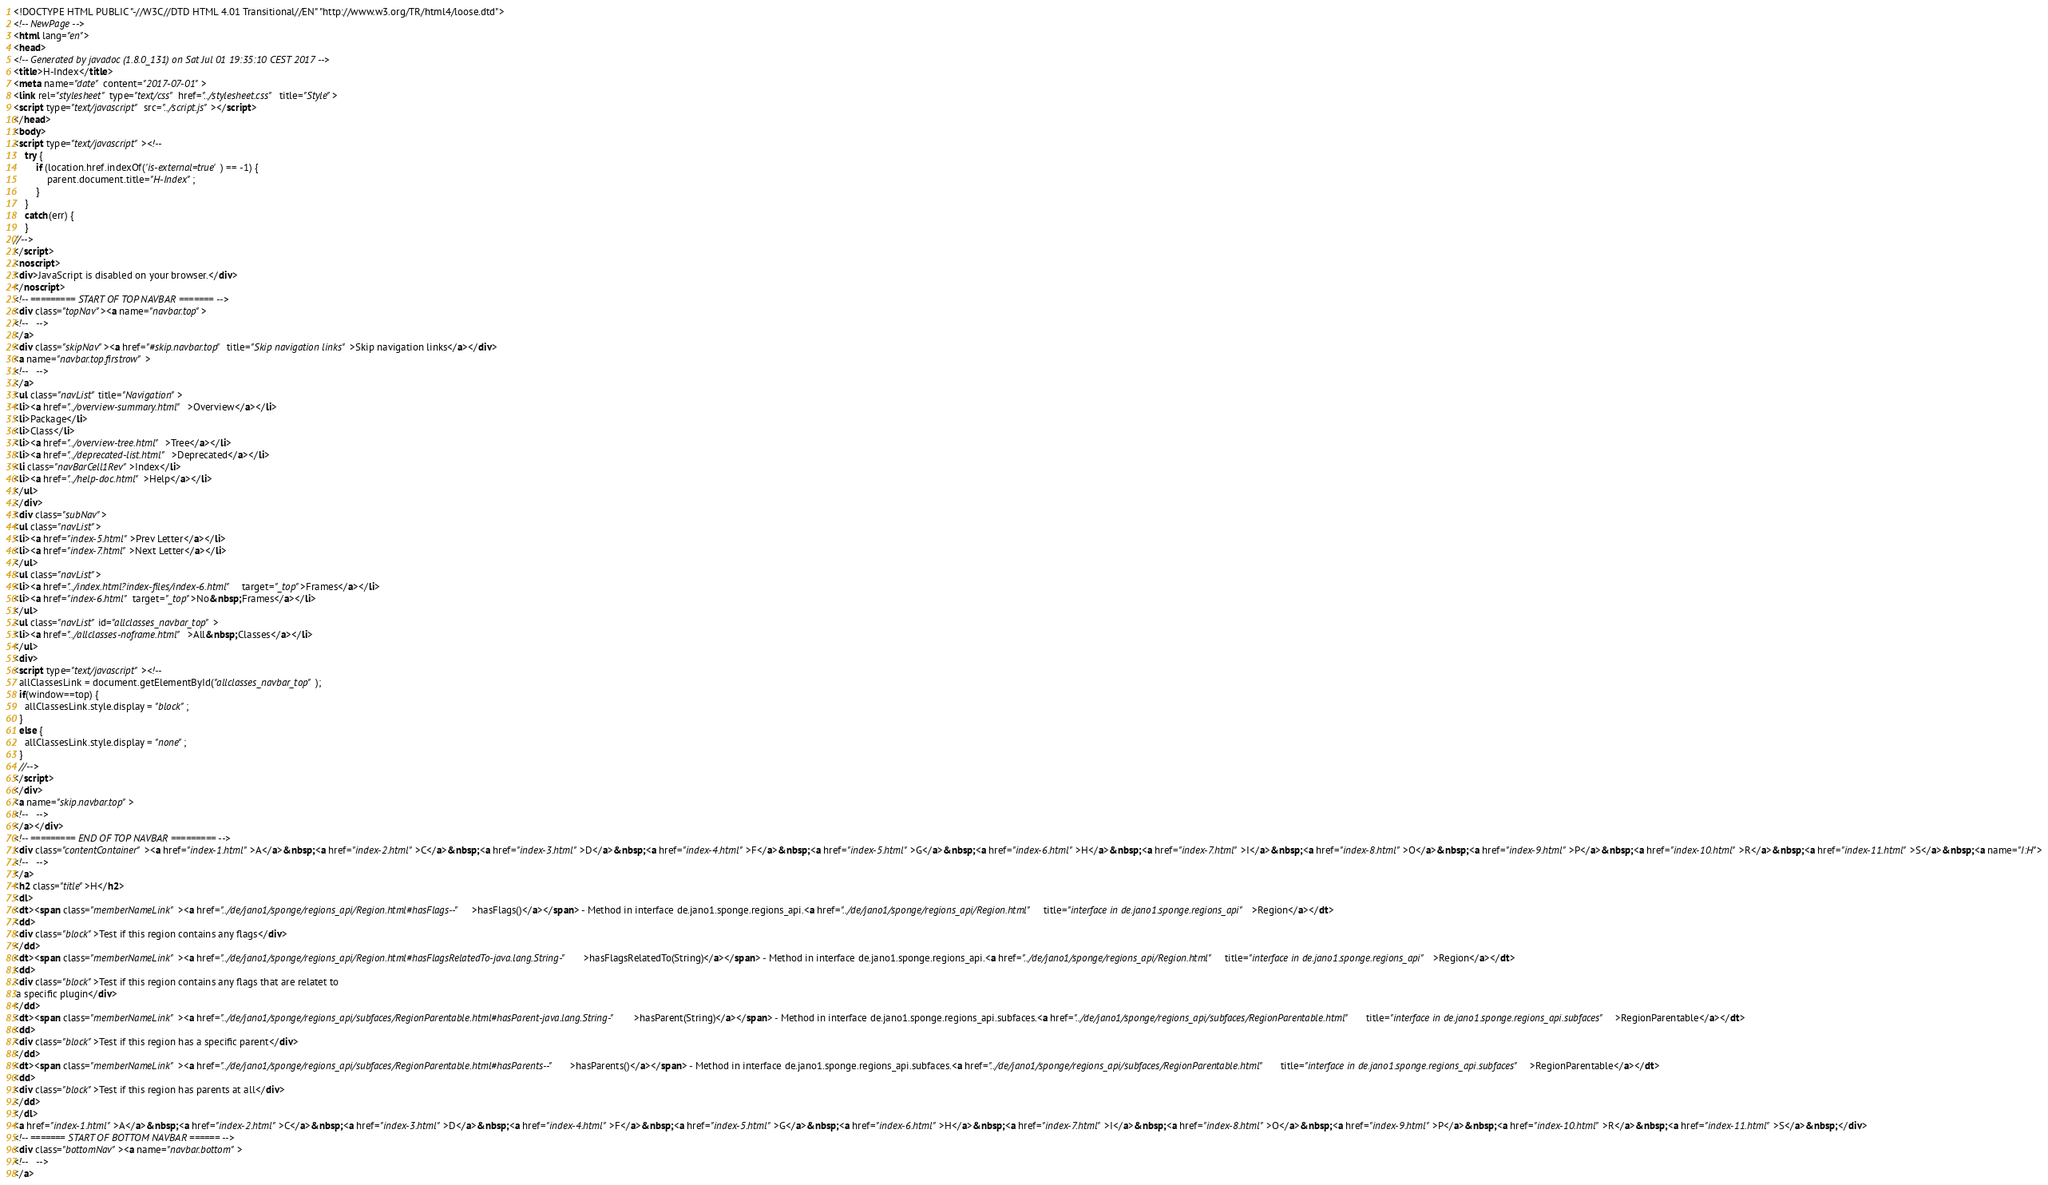<code> <loc_0><loc_0><loc_500><loc_500><_HTML_><!DOCTYPE HTML PUBLIC "-//W3C//DTD HTML 4.01 Transitional//EN" "http://www.w3.org/TR/html4/loose.dtd">
<!-- NewPage -->
<html lang="en">
<head>
<!-- Generated by javadoc (1.8.0_131) on Sat Jul 01 19:35:10 CEST 2017 -->
<title>H-Index</title>
<meta name="date" content="2017-07-01">
<link rel="stylesheet" type="text/css" href="../stylesheet.css" title="Style">
<script type="text/javascript" src="../script.js"></script>
</head>
<body>
<script type="text/javascript"><!--
    try {
        if (location.href.indexOf('is-external=true') == -1) {
            parent.document.title="H-Index";
        }
    }
    catch(err) {
    }
//-->
</script>
<noscript>
<div>JavaScript is disabled on your browser.</div>
</noscript>
<!-- ========= START OF TOP NAVBAR ======= -->
<div class="topNav"><a name="navbar.top">
<!--   -->
</a>
<div class="skipNav"><a href="#skip.navbar.top" title="Skip navigation links">Skip navigation links</a></div>
<a name="navbar.top.firstrow">
<!--   -->
</a>
<ul class="navList" title="Navigation">
<li><a href="../overview-summary.html">Overview</a></li>
<li>Package</li>
<li>Class</li>
<li><a href="../overview-tree.html">Tree</a></li>
<li><a href="../deprecated-list.html">Deprecated</a></li>
<li class="navBarCell1Rev">Index</li>
<li><a href="../help-doc.html">Help</a></li>
</ul>
</div>
<div class="subNav">
<ul class="navList">
<li><a href="index-5.html">Prev Letter</a></li>
<li><a href="index-7.html">Next Letter</a></li>
</ul>
<ul class="navList">
<li><a href="../index.html?index-files/index-6.html" target="_top">Frames</a></li>
<li><a href="index-6.html" target="_top">No&nbsp;Frames</a></li>
</ul>
<ul class="navList" id="allclasses_navbar_top">
<li><a href="../allclasses-noframe.html">All&nbsp;Classes</a></li>
</ul>
<div>
<script type="text/javascript"><!--
  allClassesLink = document.getElementById("allclasses_navbar_top");
  if(window==top) {
    allClassesLink.style.display = "block";
  }
  else {
    allClassesLink.style.display = "none";
  }
  //-->
</script>
</div>
<a name="skip.navbar.top">
<!--   -->
</a></div>
<!-- ========= END OF TOP NAVBAR ========= -->
<div class="contentContainer"><a href="index-1.html">A</a>&nbsp;<a href="index-2.html">C</a>&nbsp;<a href="index-3.html">D</a>&nbsp;<a href="index-4.html">F</a>&nbsp;<a href="index-5.html">G</a>&nbsp;<a href="index-6.html">H</a>&nbsp;<a href="index-7.html">I</a>&nbsp;<a href="index-8.html">O</a>&nbsp;<a href="index-9.html">P</a>&nbsp;<a href="index-10.html">R</a>&nbsp;<a href="index-11.html">S</a>&nbsp;<a name="I:H">
<!--   -->
</a>
<h2 class="title">H</h2>
<dl>
<dt><span class="memberNameLink"><a href="../de/jano1/sponge/regions_api/Region.html#hasFlags--">hasFlags()</a></span> - Method in interface de.jano1.sponge.regions_api.<a href="../de/jano1/sponge/regions_api/Region.html" title="interface in de.jano1.sponge.regions_api">Region</a></dt>
<dd>
<div class="block">Test if this region contains any flags</div>
</dd>
<dt><span class="memberNameLink"><a href="../de/jano1/sponge/regions_api/Region.html#hasFlagsRelatedTo-java.lang.String-">hasFlagsRelatedTo(String)</a></span> - Method in interface de.jano1.sponge.regions_api.<a href="../de/jano1/sponge/regions_api/Region.html" title="interface in de.jano1.sponge.regions_api">Region</a></dt>
<dd>
<div class="block">Test if this region contains any flags that are relatet to
 a specific plugin</div>
</dd>
<dt><span class="memberNameLink"><a href="../de/jano1/sponge/regions_api/subfaces/RegionParentable.html#hasParent-java.lang.String-">hasParent(String)</a></span> - Method in interface de.jano1.sponge.regions_api.subfaces.<a href="../de/jano1/sponge/regions_api/subfaces/RegionParentable.html" title="interface in de.jano1.sponge.regions_api.subfaces">RegionParentable</a></dt>
<dd>
<div class="block">Test if this region has a specific parent</div>
</dd>
<dt><span class="memberNameLink"><a href="../de/jano1/sponge/regions_api/subfaces/RegionParentable.html#hasParents--">hasParents()</a></span> - Method in interface de.jano1.sponge.regions_api.subfaces.<a href="../de/jano1/sponge/regions_api/subfaces/RegionParentable.html" title="interface in de.jano1.sponge.regions_api.subfaces">RegionParentable</a></dt>
<dd>
<div class="block">Test if this region has parents at all</div>
</dd>
</dl>
<a href="index-1.html">A</a>&nbsp;<a href="index-2.html">C</a>&nbsp;<a href="index-3.html">D</a>&nbsp;<a href="index-4.html">F</a>&nbsp;<a href="index-5.html">G</a>&nbsp;<a href="index-6.html">H</a>&nbsp;<a href="index-7.html">I</a>&nbsp;<a href="index-8.html">O</a>&nbsp;<a href="index-9.html">P</a>&nbsp;<a href="index-10.html">R</a>&nbsp;<a href="index-11.html">S</a>&nbsp;</div>
<!-- ======= START OF BOTTOM NAVBAR ====== -->
<div class="bottomNav"><a name="navbar.bottom">
<!--   -->
</a></code> 